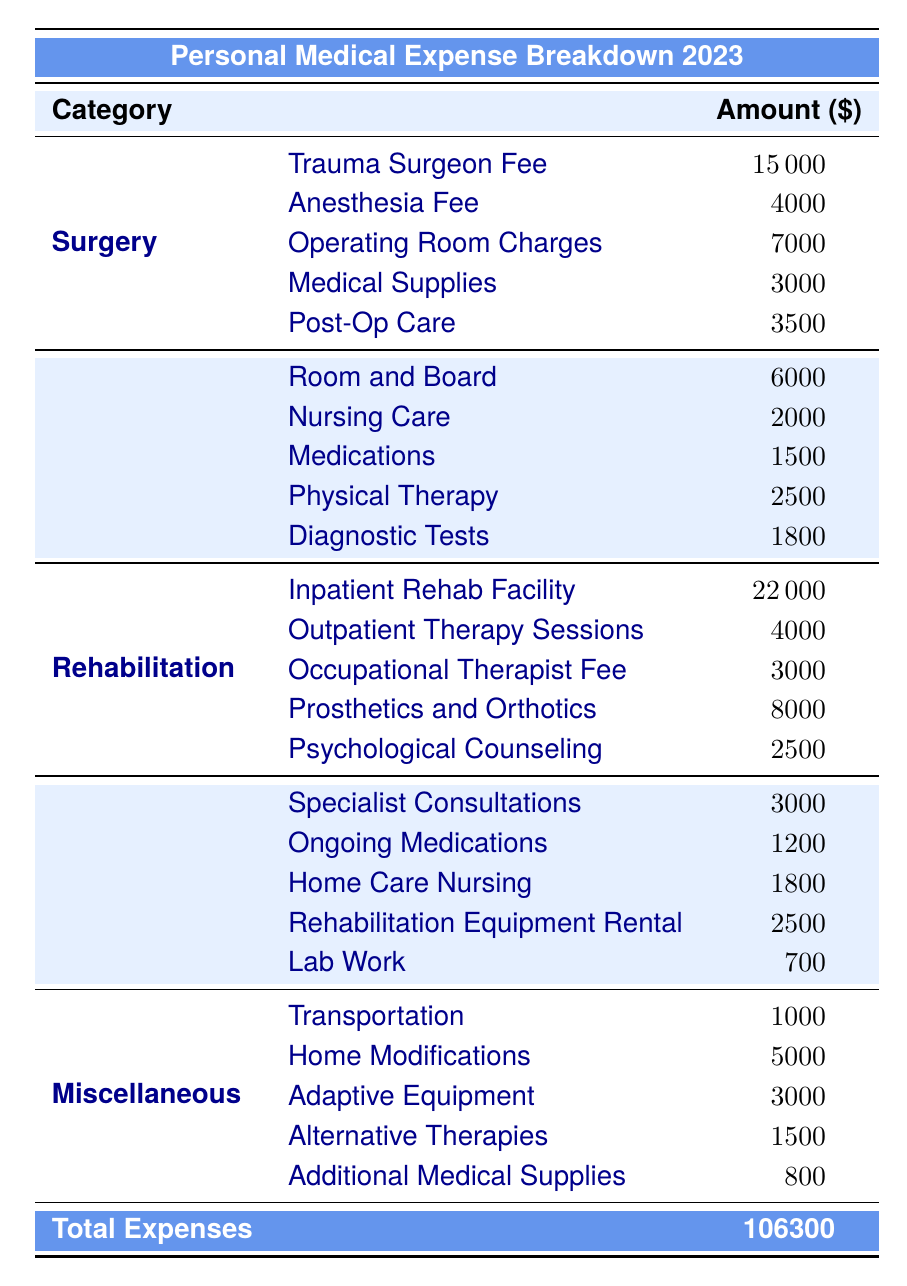What is the total amount spent on surgery? To find the total amount spent on surgery, I need to sum the individual costs within the Surgery category: Trauma Surgeon Fee (15000) + Anesthesia Fee (4000) + Operating Room Charges (7000) + Medical Supplies (3000) + Post-Op Care (3500). Adding these values gives 15000 + 4000 + 7000 + 3000 + 3500 = 30000.
Answer: 30000 How much was spent on the hospital stay compared to rehabilitation? The total amount spent on the hospital stay is calculated by summing: Room and Board (6000) + Nursing Care (2000) + Medications (1500) + Physical Therapy (2500) + Diagnostic Tests (1800), resulting in 6000 + 2000 + 1500 + 2500 + 1800 = 13800. For rehabilitation, the total is Inpatient Rehab Facility (22000) + Outpatient Therapy Sessions (4000) + Occupational Therapist Fee (3000) + Prosthetics and Orthotics (8000) + Psychological Counseling (2500), which results in 22000 + 4000 + 3000 + 8000 + 2500 = 40000. Thus, rehabilitation costs 40000, whereas the hospital stay costs 13800.
Answer: Rehabilitation costs 40000; hospital stay costs 13800 Is the cost of the trauma surgeon fee higher than the total spent on follow-up care? The trauma surgeon fee is 15000. To find the total follow-up care cost, I sum the costs: Specialist Consultations (3000) + Ongoing Medications (1200) + Home Care Nursing (1800) + Rehabilitation Equipment Rental (2500) + Lab Work (700), resulting in 3000 + 1200 + 1800 + 2500 + 700 = 9200. Since 15000 is greater than 9200, the statement is true.
Answer: Yes What is the average cost of rehabilitation services? First, I sum the costs within the Rehabilitation category: Inpatient Rehab Facility (22000) + Outpatient Therapy Sessions (4000) + Occupational Therapist Fee (3000) + Prosthetics and Orthotics (8000) + Psychological Counseling (2500) = 40000. There are 5 services, so the average is calculated by dividing the total cost by the number of services: 40000 / 5 = 8000.
Answer: 8000 Did the total miscellaneous expenses exceed the hospital stay expenses? The total miscellaneous expenses are calculated by summing: Transportation (1000) + Home Modifications (5000) + Adaptive Equipment (3000) + Alternative Therapies (1500) + Additional Medical Supplies (800), which gives 1000 + 5000 + 3000 + 1500 + 800 = 11300. The total hospital stay costs 13800. Since 11300 is less than 13800, the statement is false.
Answer: No What is the percentage of total expenses spent on psychological counseling? The total expenses amount to 106300. The cost of psychological counseling is 2500. To find the percentage, I divide the cost of psychological counseling by the total expenses and multiply by 100: (2500 / 106300) * 100 = 2.35%.
Answer: 2.35% 